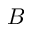<formula> <loc_0><loc_0><loc_500><loc_500>B</formula> 